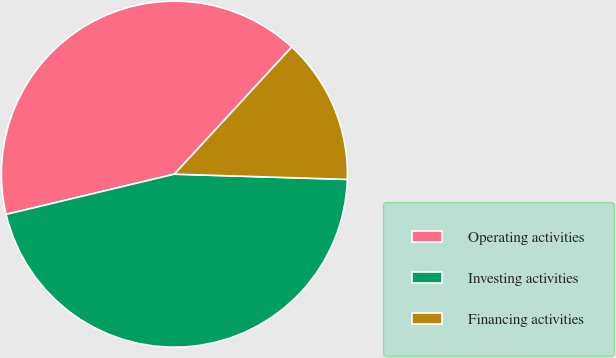Convert chart. <chart><loc_0><loc_0><loc_500><loc_500><pie_chart><fcel>Operating activities<fcel>Investing activities<fcel>Financing activities<nl><fcel>40.6%<fcel>45.78%<fcel>13.62%<nl></chart> 